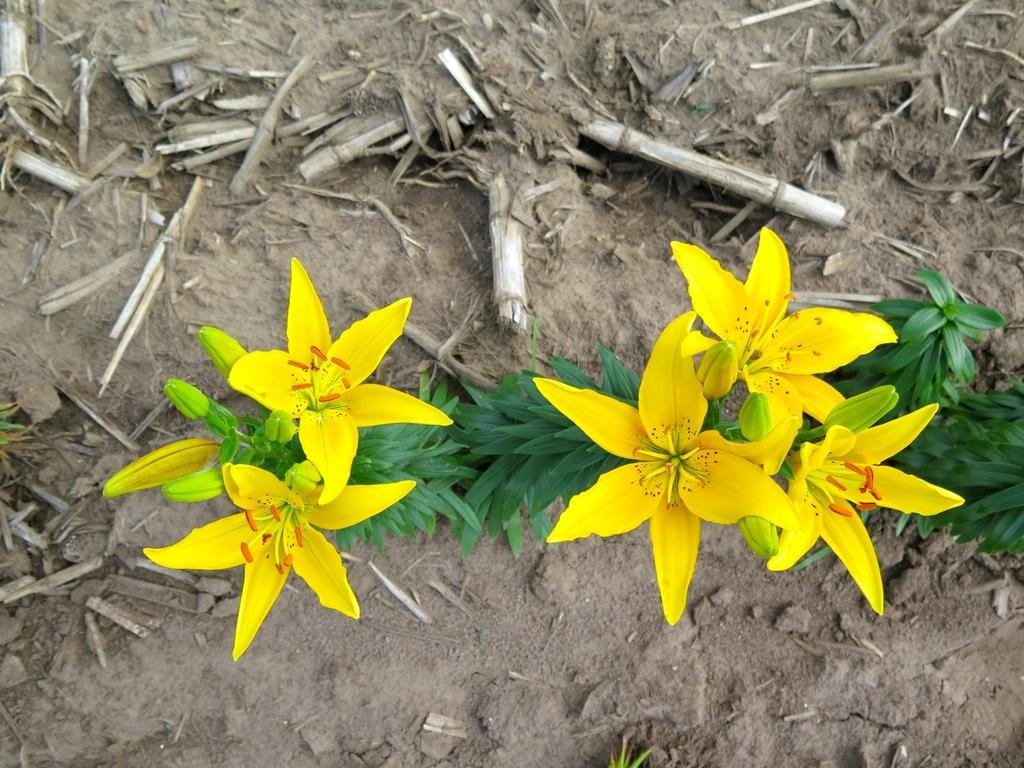What type of flowers can be seen in the foreground of the image? There are yellow colored flowers in the foreground of the image. What stage of growth are the plants in the foreground? There are buds on the plants in the foreground. What can be seen on the ground in the background of the image? In the background, there are sticks on the ground. What is your sister doing with the cow in the image? There is no mention of a sister or a cow in the image; the facts provided only discuss flowers, buds, and sticks. 